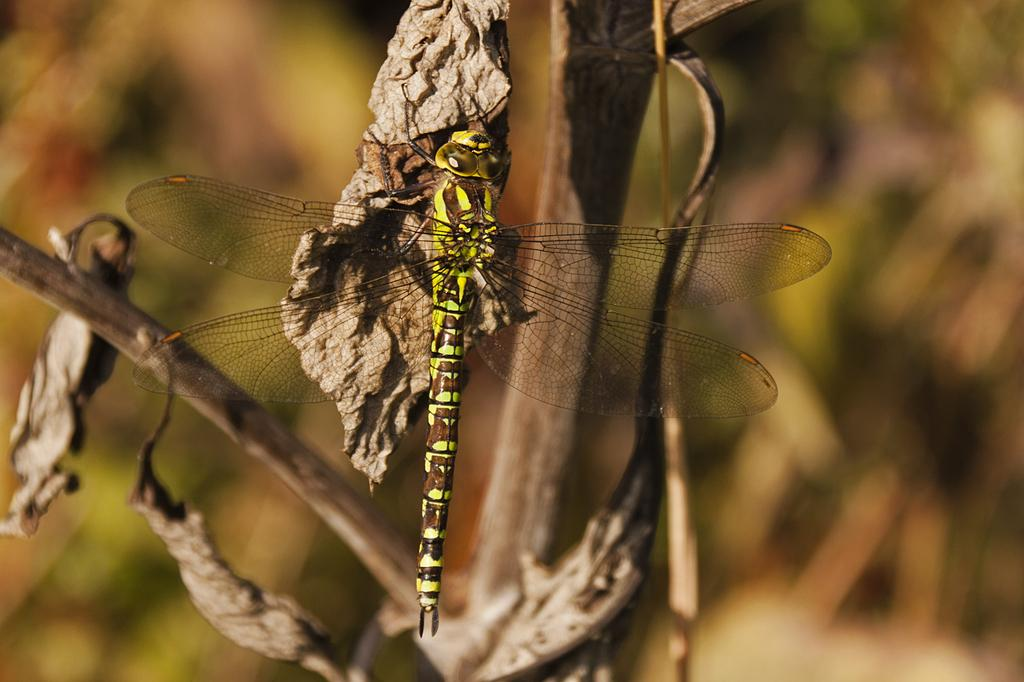What insect is present in the image? There is a dragonfly in the image. What is the dragonfly resting on? The dragonfly is on a dried leaf. What colors can be seen on the dragonfly? The dragonfly has yellow and brown colors. How would you describe the background of the image? The background of the image is blurred. What type of furniture can be seen in the image? There is no furniture present in the image; it features a dragonfly on a dried leaf. 